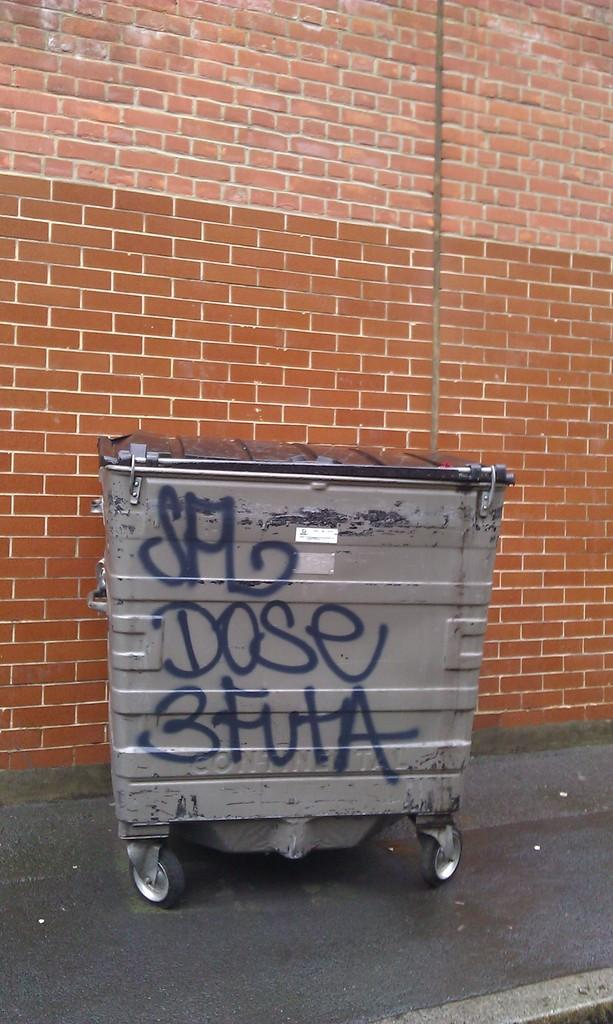<image>
Give a short and clear explanation of the subsequent image. A dumpster with dose 3 futa graffiti sits next to a brick building. 